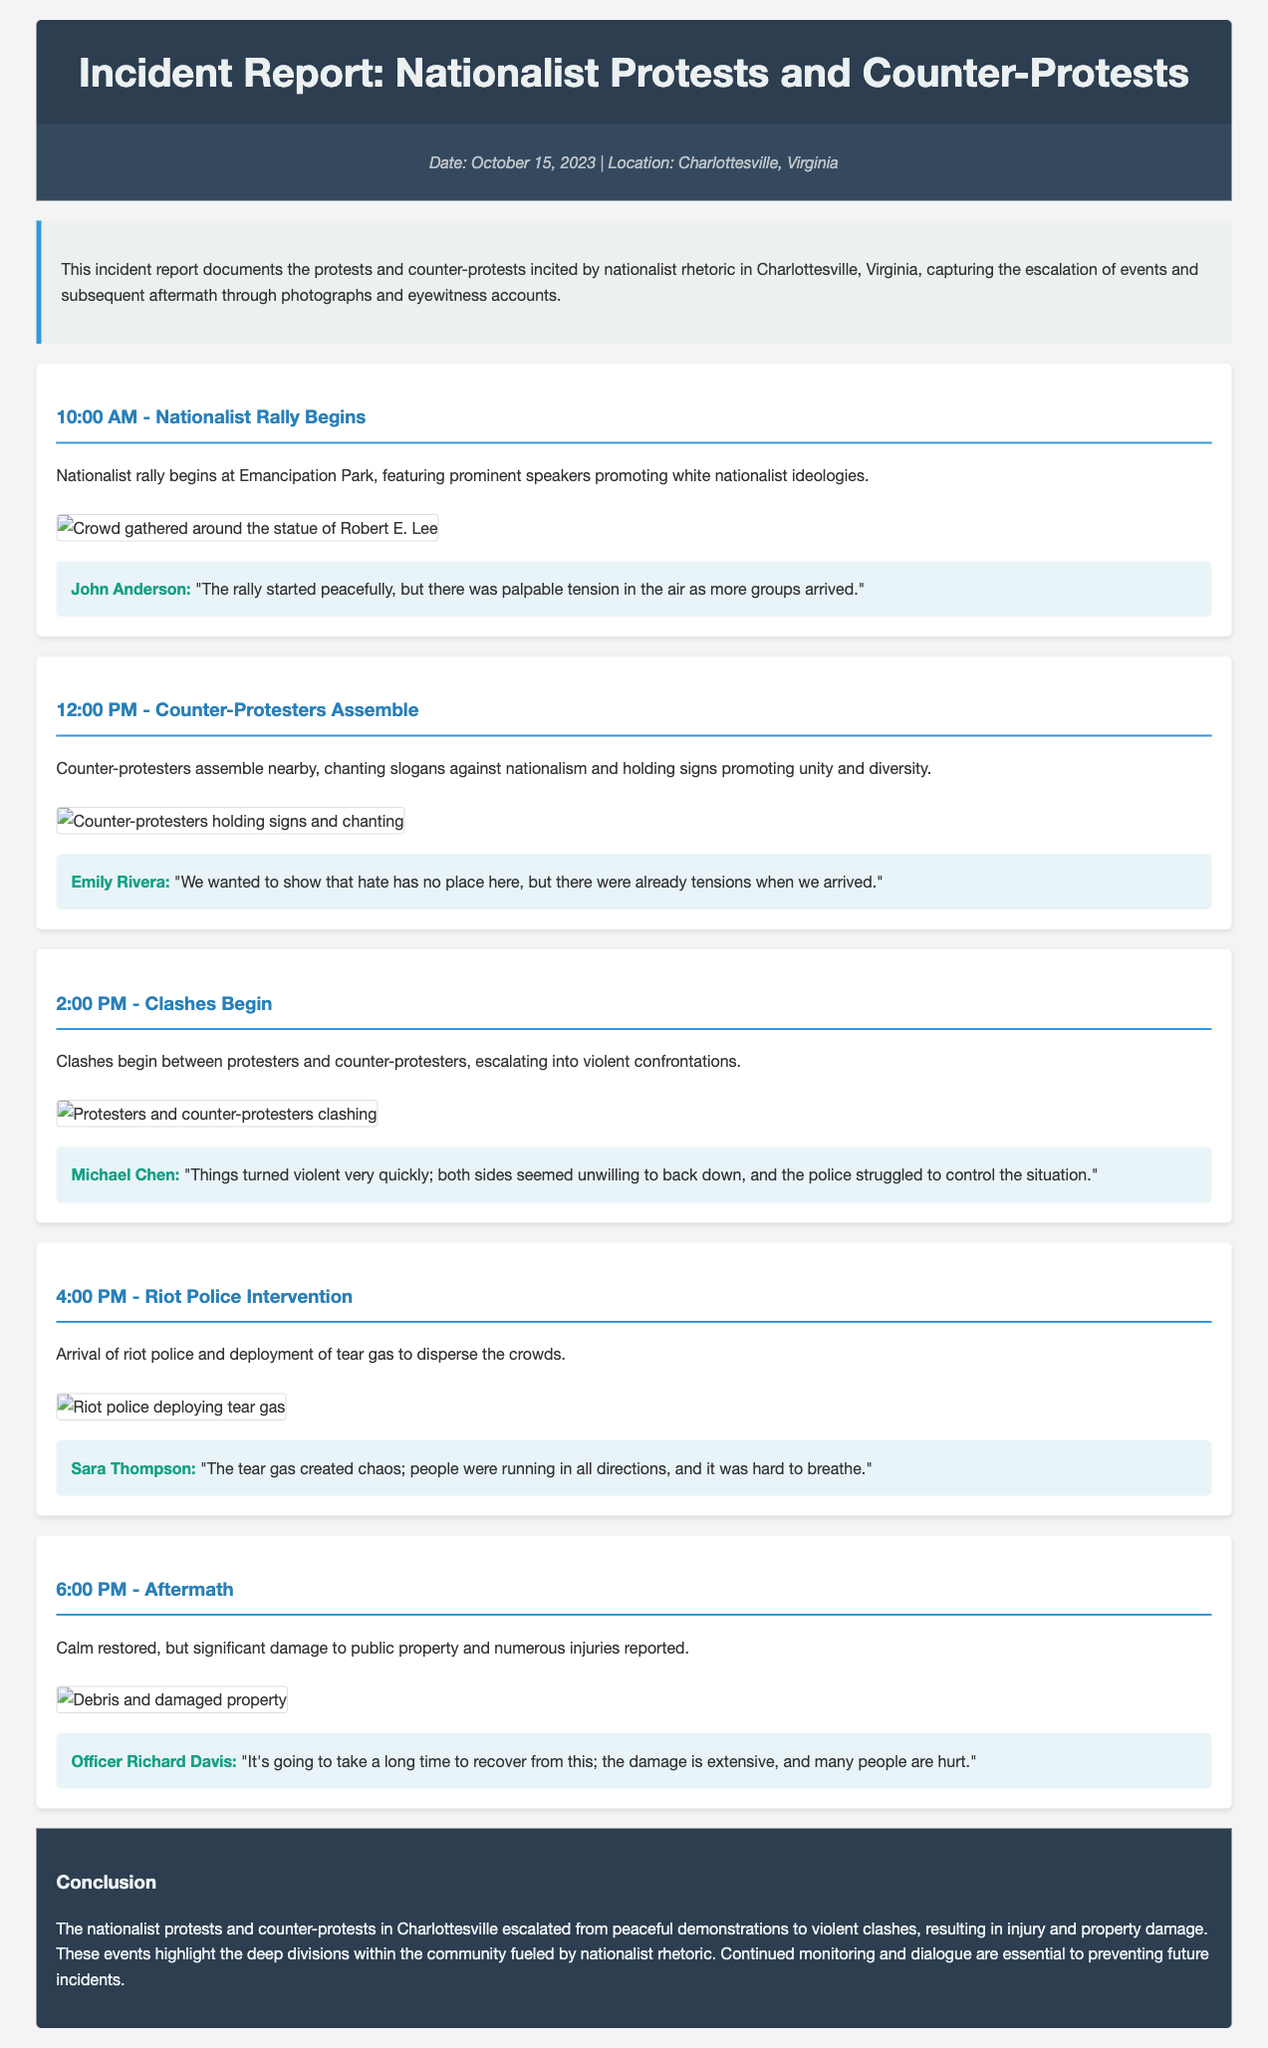What time did the nationalist rally begin? The document states that the nationalist rally began at 10:00 AM.
Answer: 10:00 AM What was the location of the incident? The report mentions that the location of the protests and counter-protests was Charlottesville, Virginia.
Answer: Charlottesville, Virginia Who provided an eyewitness account of the rally? John Anderson is cited as providing an eyewitness account of the rally's beginning.
Answer: John Anderson At what time did the clashes begin? The document indicates that clashes began at 2:00 PM.
Answer: 2:00 PM What was used by riot police to disperse crowds? The document states that tear gas was deployed by riot police to disperse the crowds.
Answer: Tear gas How did Officer Richard Davis describe the aftermath? Officer Richard Davis described the aftermath as extensive damage and many people hurt.
Answer: Extensive damage What were the counter-protesters promoting? The counter-protesters were promoting unity and diversity through their chant slogans and signs.
Answer: Unity and diversity What caused chaos according to eyewitness Sara Thompson? Eyewitness Sara Thompson stated that the tear gas created chaos.
Answer: Tear gas What does the conclusion highlight about community divisions? The conclusion highlights that these events demonstrate the deep divisions within the community.
Answer: Deep divisions 